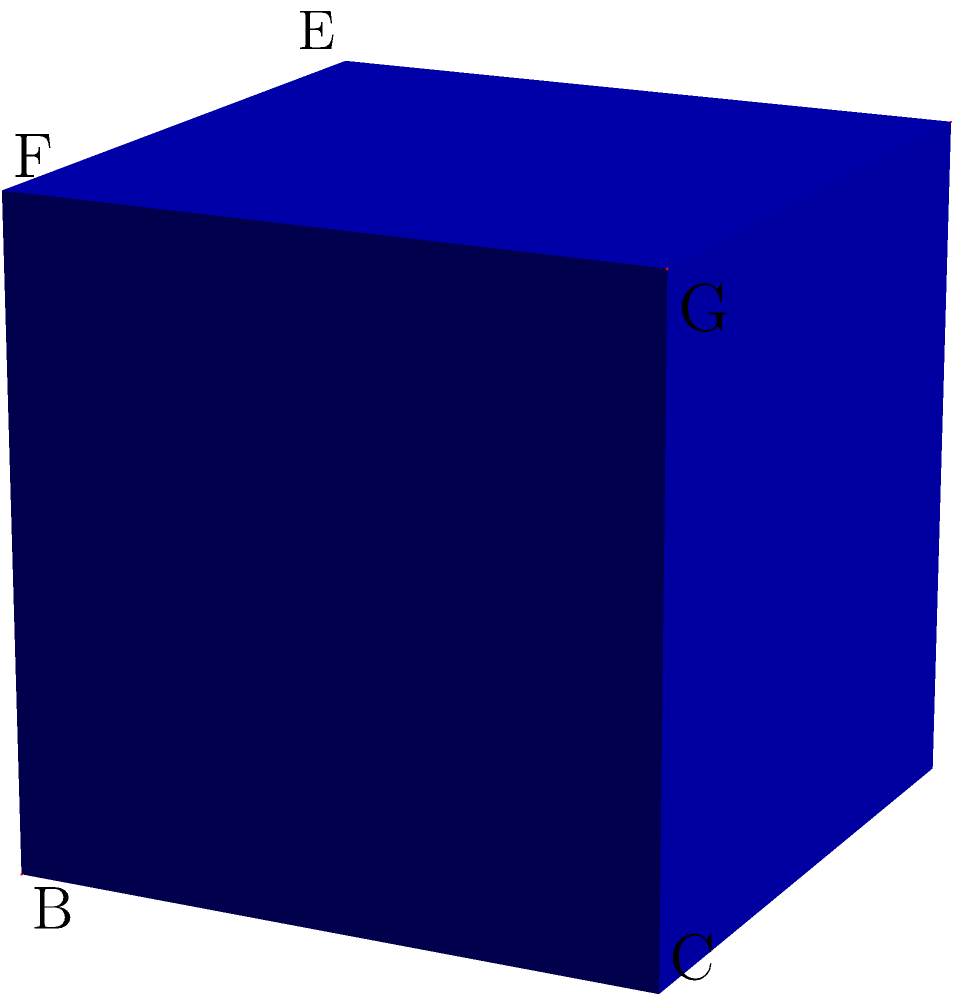In the cryptic depths of a cube, two planes intersect along the space diagonal. One plane contains vertices A, B, and G, while the other contains C, D, and F. What is the acute angle between these enigmatic planes? To solve this mystery, we shall follow these cryptographic steps:

1) The normal vectors of the planes are key to unlocking this puzzle:
   - For plane ABG: $\vec{n_1} = \vec{AB} \times \vec{AG} = (1,0,0) \times (1,1,1) = (0,1,-1)$
   - For plane CDF: $\vec{n_2} = \vec{CD} \times \vec{CF} = (-1,1,0) \times (0,-1,1) = (1,1,1)$

2) The angle between the planes is the complement of the angle between their normal vectors. We can use the dot product formula:

   $\cos \theta = \frac{\vec{n_1} \cdot \vec{n_2}}{|\vec{n_1}||\vec{n_2}|}$

3) Calculate the dot product:
   $\vec{n_1} \cdot \vec{n_2} = 0(1) + 1(1) + (-1)(1) = 0$

4) Calculate the magnitudes:
   $|\vec{n_1}| = \sqrt{0^2 + 1^2 + (-1)^2} = \sqrt{2}$
   $|\vec{n_2}| = \sqrt{1^2 + 1^2 + 1^2} = \sqrt{3}$

5) Substitute into the formula:
   $\cos \theta = \frac{0}{\sqrt{2}\sqrt{3}} = 0$

6) Therefore, $\theta = \arccos(0) = 90°$

7) The acute angle between the planes is the complement of this angle:
   $90° - 90° = 0°$

Thus, the planes are parallel, intersecting only at infinity along the space diagonal.
Answer: $0°$ 